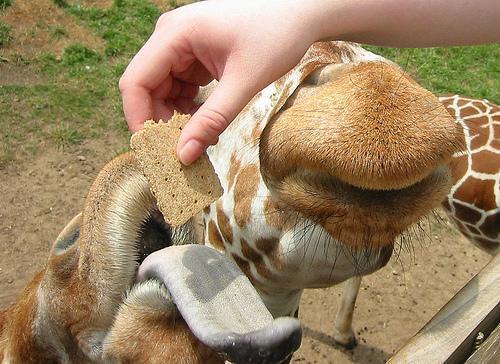How many animals are in this picture?
Give a very brief answer. 2. How many giraffes are pictured here?
Give a very brief answer. 3. How many giraffe tongues are visible?
Give a very brief answer. 1. How many giraffe noses are visible?
Give a very brief answer. 2. How many hands are in the photo?
Give a very brief answer. 1. 